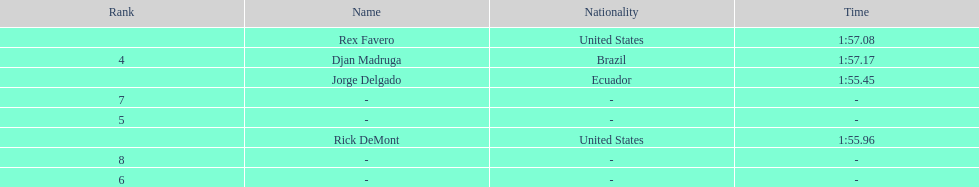08? 1:57.17. 